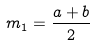Convert formula to latex. <formula><loc_0><loc_0><loc_500><loc_500>m _ { 1 } = \frac { a + b } { 2 }</formula> 